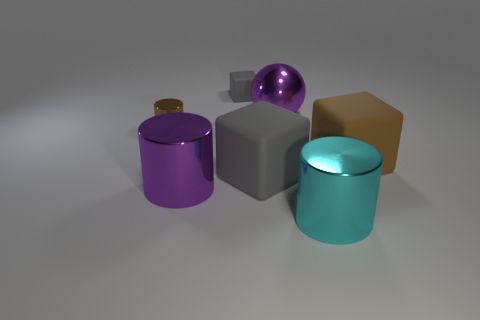There is a large purple metal thing left of the large purple sphere; are there any large gray blocks that are in front of it?
Offer a terse response. No. There is a metallic cylinder in front of the big purple cylinder; what color is it?
Your answer should be very brief. Cyan. Is the number of cylinders in front of the brown cylinder the same as the number of matte things?
Provide a succinct answer. No. There is a big shiny thing that is both on the right side of the big purple cylinder and in front of the large gray rubber cube; what shape is it?
Your answer should be compact. Cylinder. What is the color of the small rubber thing that is the same shape as the big brown rubber object?
Give a very brief answer. Gray. Is there anything else that has the same color as the small rubber block?
Give a very brief answer. Yes. What is the shape of the gray rubber thing in front of the brown thing that is right of the large shiny object that is left of the tiny gray rubber object?
Make the answer very short. Cube. There is a gray thing behind the big gray rubber cube; is it the same size as the brown thing that is right of the large cyan metal cylinder?
Keep it short and to the point. No. What number of gray things are the same material as the small brown object?
Keep it short and to the point. 0. There is a big cylinder that is in front of the large purple object in front of the big brown matte block; what number of spheres are on the right side of it?
Keep it short and to the point. 0. 